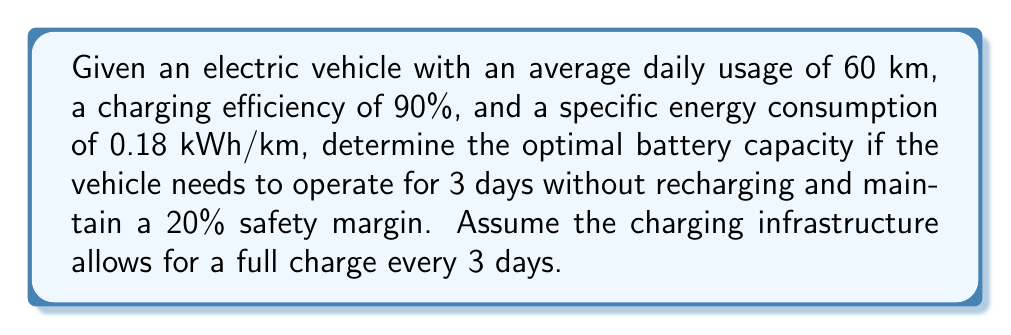Provide a solution to this math problem. To solve this inverse problem and determine the optimal battery capacity, we'll follow these steps:

1. Calculate the total energy required for 3 days of usage:
   $$E_{total} = \text{Daily Usage} \times \text{Days} \times \text{Energy Consumption}$$
   $$E_{total} = 60 \text{ km} \times 3 \text{ days} \times 0.18 \text{ kWh/km} = 32.4 \text{ kWh}$$

2. Account for the charging efficiency:
   $$E_{adjusted} = \frac{E_{total}}{\text{Charging Efficiency}}$$
   $$E_{adjusted} = \frac{32.4 \text{ kWh}}{0.90} = 36 \text{ kWh}$$

3. Add the safety margin:
   $$E_{with\_margin} = E_{adjusted} \times (1 + \text{Safety Margin})$$
   $$E_{with\_margin} = 36 \text{ kWh} \times (1 + 0.20) = 43.2 \text{ kWh}$$

4. Round up to the nearest whole number for practical implementation:
   $$E_{optimal} = \lceil E_{with\_margin} \rceil = 44 \text{ kWh}$$

Therefore, the optimal battery capacity for the electric vehicle is 44 kWh.
Answer: 44 kWh 